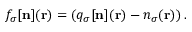Convert formula to latex. <formula><loc_0><loc_0><loc_500><loc_500>f _ { \sigma } [ { n } ] ( { r } ) = \left ( q _ { \sigma } [ { n } ] ( { r } ) - n _ { \sigma } ( { r } ) \right ) .</formula> 